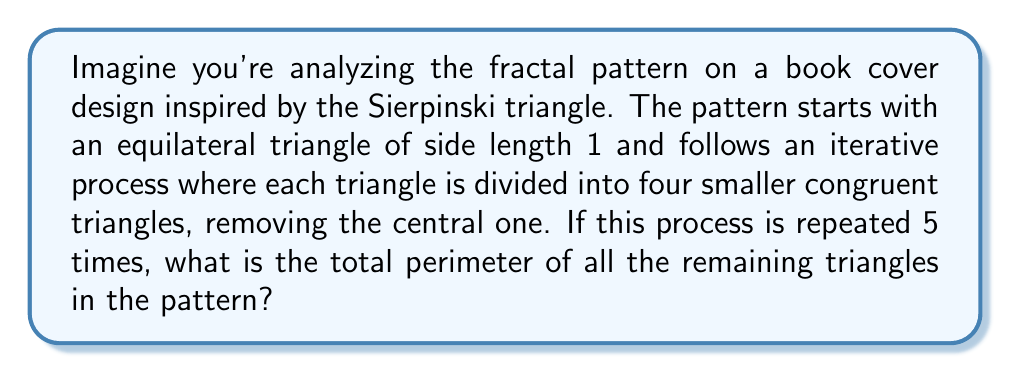What is the answer to this math problem? Let's approach this step-by-step:

1) First, we need to understand how the number of triangles and their side lengths change with each iteration:

   Iteration 0: 1 triangle, side length 1
   Iteration 1: 3 triangles, side length 1/2
   Iteration 2: 9 triangles, side length 1/4
   ...and so on

2) We can see that after n iterations:
   - Number of triangles: $3^n$
   - Side length: $(1/2)^n$

3) For 5 iterations:
   - Number of triangles: $3^5 = 243$
   - Side length: $(1/2)^5 = 1/32$

4) Each triangle has 3 sides, so the total number of sides is:
   $243 * 3 = 729$

5) The perimeter of each small triangle is:
   $3 * (1/32) = 3/32$

6) Therefore, the total perimeter is:
   $729 * (3/32) = 2187/32 = 68.34375$

This fractal pattern creates a delicate lace-like design on the book cover, reminiscent of the intricate narrative structures often found in complex literary works.
Answer: $\frac{2187}{32}$ or approximately 68.34375 